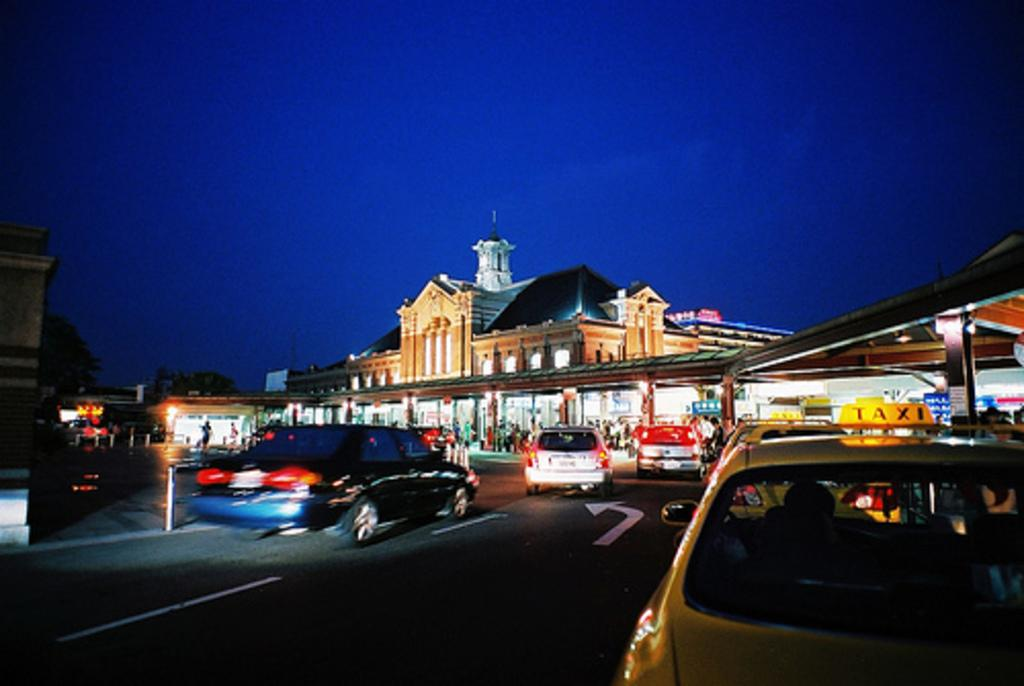<image>
Offer a succinct explanation of the picture presented. a taxi that is outside in front of a well lit town area 